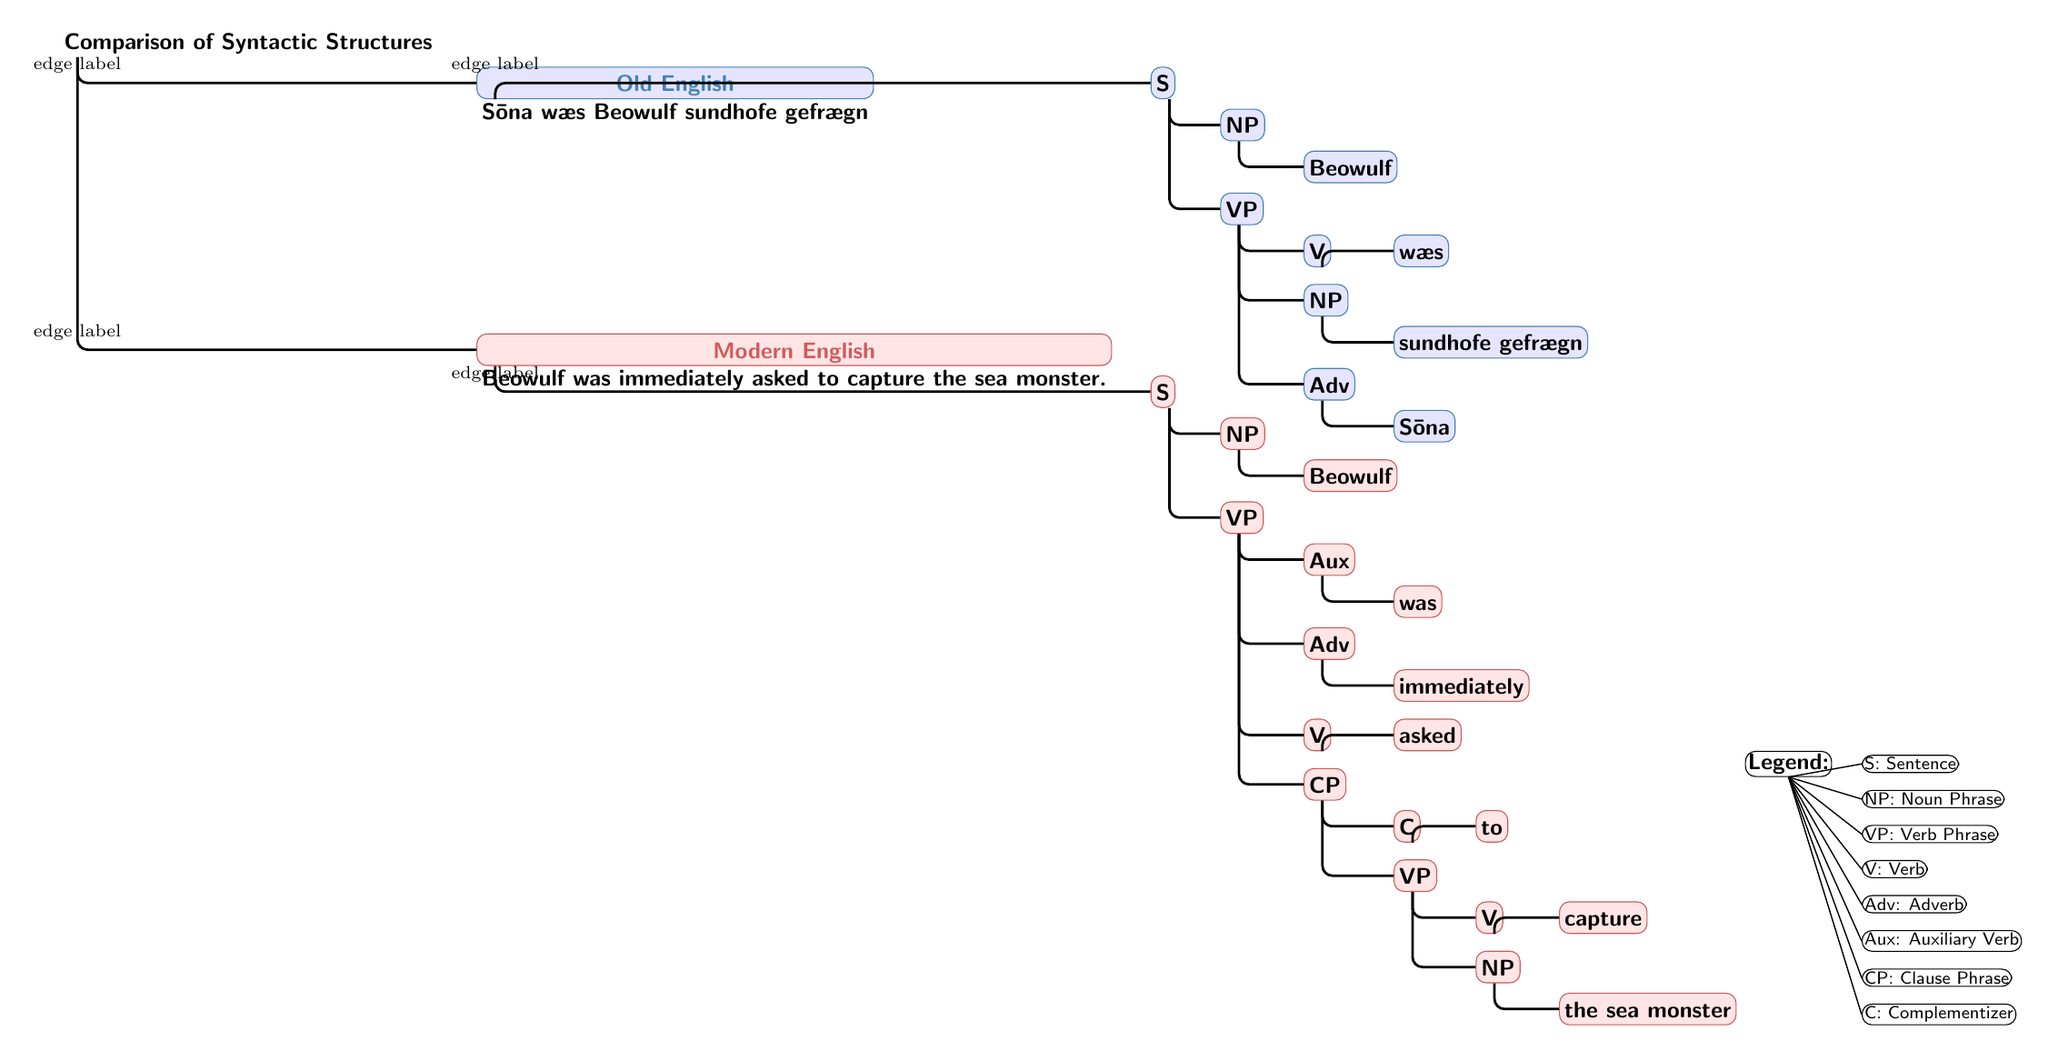What is the main comparison presented in the diagram? The diagram presents a comparison of syntactic structures in Old English and Modern English, indicated by the title "Comparison of Syntactic Structures."
Answer: Syntactic Structures How many main phrases are there in the Old English tree? In the Old English tree (the left side of the diagram), there are two main phrases under the S: NP (Noun Phrase) and VP (Verb Phrase), making a total of two.
Answer: 2 What is the auxiliary verb represented in the Modern English tree? In the Modern English tree, the auxiliary verb is shown as "was," which is directly under the VP containing the auxiliary verb.
Answer: was Which phrase structure is represented as "CP" in the Modern English tree? The "CP" (Clause Phrase) represented in the Modern English tree is the phrase that follows “Aux [was]” and includes a complementizer and further verb phrase information to capture the sea monster.
Answer: to What is the color used to represent Old English in the diagram? Old English is represented using a bluish color, specifically a shade called "oldEnglishColor," which is a mix suitable for highlighting the Old English structure.
Answer: blue Which elements precede the main verb in the VP of Modern English? In the Modern English tree, the elements that precede the main verb "asked" in the VP are the auxiliary verb "was" and the adverb "immediately," which adds context to the action described.
Answer: was, immediately How many edges does the entire structure of the Old English tree contain? The Old English tree contains five edges: two leading from S to sub-phrases (NP and VP), and three additional edges leading from VP to its constituents (V, NP, and Adv).
Answer: 5 What is the purpose of the legends included in the diagram? The legends provide definitions or explanations of the abbreviations used in the trees such as S for Sentence, NP for Noun Phrase, VP for Verb Phrase, and others, making the diagram more understandable.
Answer: Clarification What syntactic role does "sundhofe gefrægn" serve in the Old English tree? In the Old English tree, "sundhofe gefrægn" serves the role of a noun phrase (NP), which is the object of the verb "wæs," indicating what was asked about.
Answer: NP (object) 